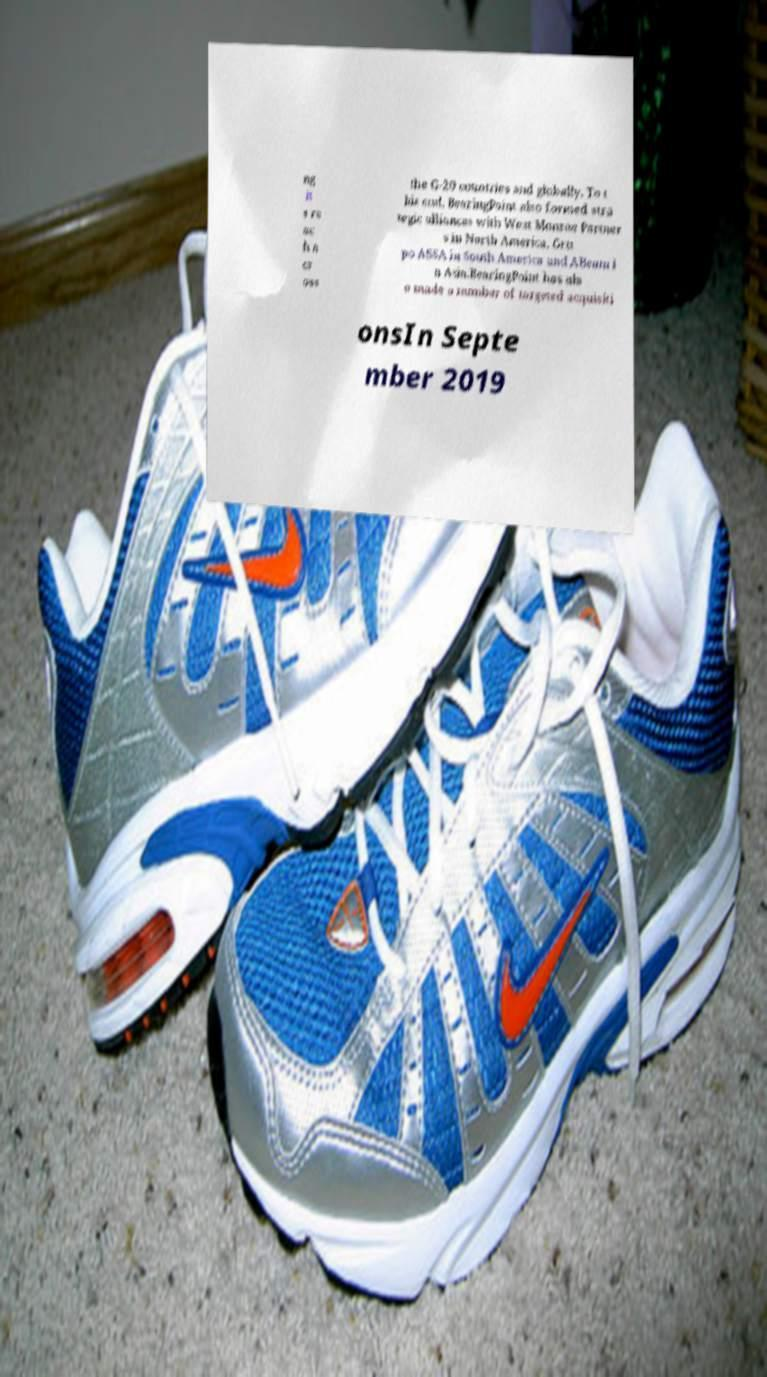There's text embedded in this image that I need extracted. Can you transcribe it verbatim? ng it s re ac h a cr oss the G-20 countries and globally. To t his end, BearingPoint also formed stra tegic alliances with West Monroe Partner s in North America, Gru po ASSA in South America and ABeam i n Asia.BearingPoint has als o made a number of targeted acquisiti onsIn Septe mber 2019 